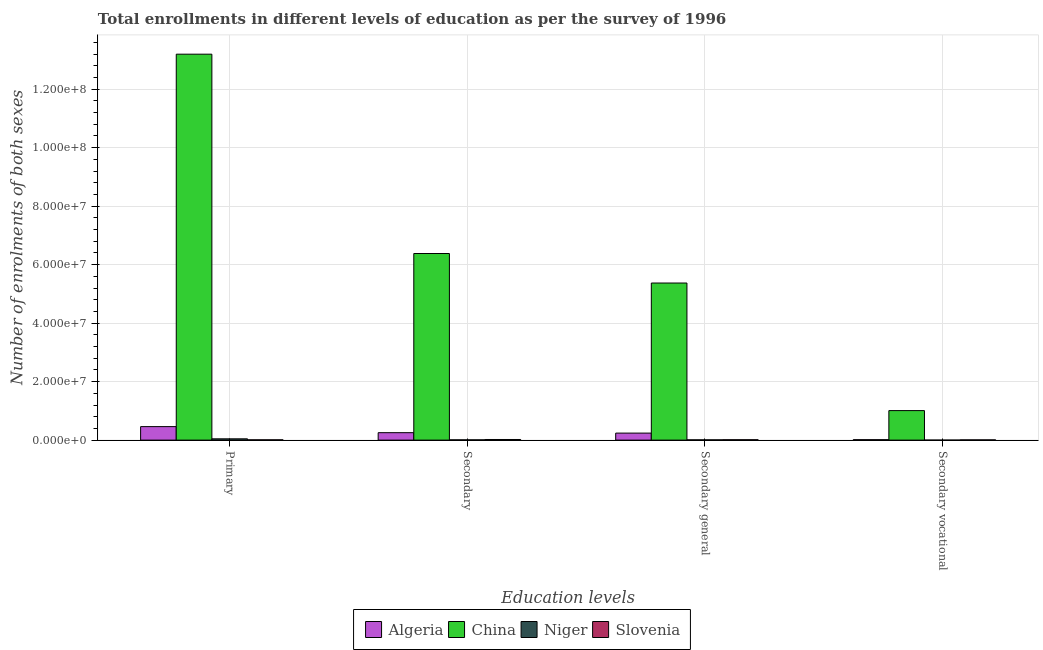How many groups of bars are there?
Your answer should be very brief. 4. How many bars are there on the 3rd tick from the right?
Offer a terse response. 4. What is the label of the 3rd group of bars from the left?
Give a very brief answer. Secondary general. What is the number of enrolments in secondary general education in Algeria?
Provide a succinct answer. 2.40e+06. Across all countries, what is the maximum number of enrolments in secondary vocational education?
Provide a succinct answer. 1.01e+07. Across all countries, what is the minimum number of enrolments in secondary general education?
Make the answer very short. 9.05e+04. In which country was the number of enrolments in secondary general education minimum?
Your answer should be very brief. Niger. What is the total number of enrolments in secondary vocational education in the graph?
Give a very brief answer. 1.03e+07. What is the difference between the number of enrolments in secondary general education in Slovenia and that in Algeria?
Offer a very short reply. -2.26e+06. What is the difference between the number of enrolments in secondary vocational education in China and the number of enrolments in secondary general education in Niger?
Your response must be concise. 1.00e+07. What is the average number of enrolments in secondary general education per country?
Your response must be concise. 1.41e+07. What is the difference between the number of enrolments in secondary education and number of enrolments in primary education in Algeria?
Make the answer very short. -2.07e+06. What is the ratio of the number of enrolments in secondary general education in Slovenia to that in Niger?
Offer a terse response. 1.48. Is the number of enrolments in secondary general education in China less than that in Niger?
Your response must be concise. No. Is the difference between the number of enrolments in primary education in Niger and Algeria greater than the difference between the number of enrolments in secondary vocational education in Niger and Algeria?
Offer a terse response. No. What is the difference between the highest and the second highest number of enrolments in primary education?
Keep it short and to the point. 1.27e+08. What is the difference between the highest and the lowest number of enrolments in secondary vocational education?
Your answer should be compact. 1.01e+07. In how many countries, is the number of enrolments in secondary vocational education greater than the average number of enrolments in secondary vocational education taken over all countries?
Offer a terse response. 1. Is the sum of the number of enrolments in secondary education in Niger and China greater than the maximum number of enrolments in secondary general education across all countries?
Your answer should be compact. Yes. What does the 1st bar from the left in Primary represents?
Make the answer very short. Algeria. What does the 2nd bar from the right in Secondary general represents?
Keep it short and to the point. Niger. How many countries are there in the graph?
Make the answer very short. 4. What is the difference between two consecutive major ticks on the Y-axis?
Your response must be concise. 2.00e+07. Does the graph contain grids?
Offer a terse response. Yes. Where does the legend appear in the graph?
Keep it short and to the point. Bottom center. What is the title of the graph?
Provide a succinct answer. Total enrollments in different levels of education as per the survey of 1996. Does "United Kingdom" appear as one of the legend labels in the graph?
Provide a short and direct response. No. What is the label or title of the X-axis?
Offer a terse response. Education levels. What is the label or title of the Y-axis?
Ensure brevity in your answer.  Number of enrolments of both sexes. What is the Number of enrolments of both sexes of Algeria in Primary?
Your answer should be compact. 4.62e+06. What is the Number of enrolments of both sexes of China in Primary?
Give a very brief answer. 1.32e+08. What is the Number of enrolments of both sexes in Niger in Primary?
Give a very brief answer. 4.41e+05. What is the Number of enrolments of both sexes in Slovenia in Primary?
Your response must be concise. 1.01e+05. What is the Number of enrolments of both sexes in Algeria in Secondary?
Ensure brevity in your answer.  2.54e+06. What is the Number of enrolments of both sexes in China in Secondary?
Keep it short and to the point. 6.38e+07. What is the Number of enrolments of both sexes of Niger in Secondary?
Provide a succinct answer. 9.26e+04. What is the Number of enrolments of both sexes in Slovenia in Secondary?
Offer a very short reply. 2.12e+05. What is the Number of enrolments of both sexes in Algeria in Secondary general?
Keep it short and to the point. 2.40e+06. What is the Number of enrolments of both sexes of China in Secondary general?
Make the answer very short. 5.37e+07. What is the Number of enrolments of both sexes in Niger in Secondary general?
Provide a short and direct response. 9.05e+04. What is the Number of enrolments of both sexes of Slovenia in Secondary general?
Ensure brevity in your answer.  1.34e+05. What is the Number of enrolments of both sexes of Algeria in Secondary vocational?
Offer a very short reply. 1.47e+05. What is the Number of enrolments of both sexes of China in Secondary vocational?
Your answer should be very brief. 1.01e+07. What is the Number of enrolments of both sexes of Niger in Secondary vocational?
Provide a succinct answer. 2138. What is the Number of enrolments of both sexes in Slovenia in Secondary vocational?
Keep it short and to the point. 7.83e+04. Across all Education levels, what is the maximum Number of enrolments of both sexes of Algeria?
Provide a succinct answer. 4.62e+06. Across all Education levels, what is the maximum Number of enrolments of both sexes in China?
Offer a terse response. 1.32e+08. Across all Education levels, what is the maximum Number of enrolments of both sexes of Niger?
Offer a terse response. 4.41e+05. Across all Education levels, what is the maximum Number of enrolments of both sexes in Slovenia?
Make the answer very short. 2.12e+05. Across all Education levels, what is the minimum Number of enrolments of both sexes in Algeria?
Keep it short and to the point. 1.47e+05. Across all Education levels, what is the minimum Number of enrolments of both sexes in China?
Keep it short and to the point. 1.01e+07. Across all Education levels, what is the minimum Number of enrolments of both sexes in Niger?
Make the answer very short. 2138. Across all Education levels, what is the minimum Number of enrolments of both sexes in Slovenia?
Give a very brief answer. 7.83e+04. What is the total Number of enrolments of both sexes of Algeria in the graph?
Your answer should be compact. 9.71e+06. What is the total Number of enrolments of both sexes in China in the graph?
Provide a succinct answer. 2.60e+08. What is the total Number of enrolments of both sexes of Niger in the graph?
Your answer should be very brief. 6.26e+05. What is the total Number of enrolments of both sexes in Slovenia in the graph?
Provide a succinct answer. 5.25e+05. What is the difference between the Number of enrolments of both sexes of Algeria in Primary and that in Secondary?
Provide a succinct answer. 2.07e+06. What is the difference between the Number of enrolments of both sexes of China in Primary and that in Secondary?
Your answer should be compact. 6.82e+07. What is the difference between the Number of enrolments of both sexes in Niger in Primary and that in Secondary?
Make the answer very short. 3.48e+05. What is the difference between the Number of enrolments of both sexes in Slovenia in Primary and that in Secondary?
Ensure brevity in your answer.  -1.11e+05. What is the difference between the Number of enrolments of both sexes in Algeria in Primary and that in Secondary general?
Provide a succinct answer. 2.22e+06. What is the difference between the Number of enrolments of both sexes of China in Primary and that in Secondary general?
Provide a short and direct response. 7.82e+07. What is the difference between the Number of enrolments of both sexes in Niger in Primary and that in Secondary general?
Provide a succinct answer. 3.50e+05. What is the difference between the Number of enrolments of both sexes of Slovenia in Primary and that in Secondary general?
Provide a short and direct response. -3.30e+04. What is the difference between the Number of enrolments of both sexes in Algeria in Primary and that in Secondary vocational?
Your answer should be compact. 4.47e+06. What is the difference between the Number of enrolments of both sexes of China in Primary and that in Secondary vocational?
Offer a terse response. 1.22e+08. What is the difference between the Number of enrolments of both sexes in Niger in Primary and that in Secondary vocational?
Give a very brief answer. 4.38e+05. What is the difference between the Number of enrolments of both sexes in Slovenia in Primary and that in Secondary vocational?
Keep it short and to the point. 2.25e+04. What is the difference between the Number of enrolments of both sexes in Algeria in Secondary and that in Secondary general?
Your answer should be compact. 1.47e+05. What is the difference between the Number of enrolments of both sexes in China in Secondary and that in Secondary general?
Your response must be concise. 1.01e+07. What is the difference between the Number of enrolments of both sexes of Niger in Secondary and that in Secondary general?
Offer a terse response. 2138. What is the difference between the Number of enrolments of both sexes of Slovenia in Secondary and that in Secondary general?
Give a very brief answer. 7.83e+04. What is the difference between the Number of enrolments of both sexes in Algeria in Secondary and that in Secondary vocational?
Your answer should be very brief. 2.40e+06. What is the difference between the Number of enrolments of both sexes of China in Secondary and that in Secondary vocational?
Offer a very short reply. 5.37e+07. What is the difference between the Number of enrolments of both sexes in Niger in Secondary and that in Secondary vocational?
Provide a succinct answer. 9.05e+04. What is the difference between the Number of enrolments of both sexes of Slovenia in Secondary and that in Secondary vocational?
Your answer should be compact. 1.34e+05. What is the difference between the Number of enrolments of both sexes in Algeria in Secondary general and that in Secondary vocational?
Keep it short and to the point. 2.25e+06. What is the difference between the Number of enrolments of both sexes of China in Secondary general and that in Secondary vocational?
Your answer should be very brief. 4.36e+07. What is the difference between the Number of enrolments of both sexes of Niger in Secondary general and that in Secondary vocational?
Keep it short and to the point. 8.83e+04. What is the difference between the Number of enrolments of both sexes of Slovenia in Secondary general and that in Secondary vocational?
Offer a terse response. 5.55e+04. What is the difference between the Number of enrolments of both sexes in Algeria in Primary and the Number of enrolments of both sexes in China in Secondary?
Make the answer very short. -5.92e+07. What is the difference between the Number of enrolments of both sexes in Algeria in Primary and the Number of enrolments of both sexes in Niger in Secondary?
Your response must be concise. 4.53e+06. What is the difference between the Number of enrolments of both sexes in Algeria in Primary and the Number of enrolments of both sexes in Slovenia in Secondary?
Your response must be concise. 4.41e+06. What is the difference between the Number of enrolments of both sexes of China in Primary and the Number of enrolments of both sexes of Niger in Secondary?
Provide a short and direct response. 1.32e+08. What is the difference between the Number of enrolments of both sexes in China in Primary and the Number of enrolments of both sexes in Slovenia in Secondary?
Give a very brief answer. 1.32e+08. What is the difference between the Number of enrolments of both sexes of Niger in Primary and the Number of enrolments of both sexes of Slovenia in Secondary?
Your answer should be very brief. 2.29e+05. What is the difference between the Number of enrolments of both sexes of Algeria in Primary and the Number of enrolments of both sexes of China in Secondary general?
Provide a succinct answer. -4.91e+07. What is the difference between the Number of enrolments of both sexes in Algeria in Primary and the Number of enrolments of both sexes in Niger in Secondary general?
Your response must be concise. 4.53e+06. What is the difference between the Number of enrolments of both sexes of Algeria in Primary and the Number of enrolments of both sexes of Slovenia in Secondary general?
Your response must be concise. 4.48e+06. What is the difference between the Number of enrolments of both sexes in China in Primary and the Number of enrolments of both sexes in Niger in Secondary general?
Make the answer very short. 1.32e+08. What is the difference between the Number of enrolments of both sexes in China in Primary and the Number of enrolments of both sexes in Slovenia in Secondary general?
Provide a succinct answer. 1.32e+08. What is the difference between the Number of enrolments of both sexes of Niger in Primary and the Number of enrolments of both sexes of Slovenia in Secondary general?
Your response must be concise. 3.07e+05. What is the difference between the Number of enrolments of both sexes in Algeria in Primary and the Number of enrolments of both sexes in China in Secondary vocational?
Make the answer very short. -5.47e+06. What is the difference between the Number of enrolments of both sexes of Algeria in Primary and the Number of enrolments of both sexes of Niger in Secondary vocational?
Give a very brief answer. 4.62e+06. What is the difference between the Number of enrolments of both sexes in Algeria in Primary and the Number of enrolments of both sexes in Slovenia in Secondary vocational?
Offer a terse response. 4.54e+06. What is the difference between the Number of enrolments of both sexes of China in Primary and the Number of enrolments of both sexes of Niger in Secondary vocational?
Offer a terse response. 1.32e+08. What is the difference between the Number of enrolments of both sexes in China in Primary and the Number of enrolments of both sexes in Slovenia in Secondary vocational?
Give a very brief answer. 1.32e+08. What is the difference between the Number of enrolments of both sexes in Niger in Primary and the Number of enrolments of both sexes in Slovenia in Secondary vocational?
Provide a short and direct response. 3.62e+05. What is the difference between the Number of enrolments of both sexes of Algeria in Secondary and the Number of enrolments of both sexes of China in Secondary general?
Provide a short and direct response. -5.12e+07. What is the difference between the Number of enrolments of both sexes of Algeria in Secondary and the Number of enrolments of both sexes of Niger in Secondary general?
Your answer should be very brief. 2.45e+06. What is the difference between the Number of enrolments of both sexes of Algeria in Secondary and the Number of enrolments of both sexes of Slovenia in Secondary general?
Ensure brevity in your answer.  2.41e+06. What is the difference between the Number of enrolments of both sexes of China in Secondary and the Number of enrolments of both sexes of Niger in Secondary general?
Give a very brief answer. 6.37e+07. What is the difference between the Number of enrolments of both sexes in China in Secondary and the Number of enrolments of both sexes in Slovenia in Secondary general?
Provide a short and direct response. 6.37e+07. What is the difference between the Number of enrolments of both sexes of Niger in Secondary and the Number of enrolments of both sexes of Slovenia in Secondary general?
Make the answer very short. -4.12e+04. What is the difference between the Number of enrolments of both sexes of Algeria in Secondary and the Number of enrolments of both sexes of China in Secondary vocational?
Your answer should be very brief. -7.55e+06. What is the difference between the Number of enrolments of both sexes in Algeria in Secondary and the Number of enrolments of both sexes in Niger in Secondary vocational?
Provide a succinct answer. 2.54e+06. What is the difference between the Number of enrolments of both sexes of Algeria in Secondary and the Number of enrolments of both sexes of Slovenia in Secondary vocational?
Your answer should be very brief. 2.47e+06. What is the difference between the Number of enrolments of both sexes of China in Secondary and the Number of enrolments of both sexes of Niger in Secondary vocational?
Ensure brevity in your answer.  6.38e+07. What is the difference between the Number of enrolments of both sexes of China in Secondary and the Number of enrolments of both sexes of Slovenia in Secondary vocational?
Provide a succinct answer. 6.37e+07. What is the difference between the Number of enrolments of both sexes of Niger in Secondary and the Number of enrolments of both sexes of Slovenia in Secondary vocational?
Give a very brief answer. 1.43e+04. What is the difference between the Number of enrolments of both sexes of Algeria in Secondary general and the Number of enrolments of both sexes of China in Secondary vocational?
Give a very brief answer. -7.69e+06. What is the difference between the Number of enrolments of both sexes in Algeria in Secondary general and the Number of enrolments of both sexes in Niger in Secondary vocational?
Your response must be concise. 2.40e+06. What is the difference between the Number of enrolments of both sexes of Algeria in Secondary general and the Number of enrolments of both sexes of Slovenia in Secondary vocational?
Offer a very short reply. 2.32e+06. What is the difference between the Number of enrolments of both sexes in China in Secondary general and the Number of enrolments of both sexes in Niger in Secondary vocational?
Provide a succinct answer. 5.37e+07. What is the difference between the Number of enrolments of both sexes in China in Secondary general and the Number of enrolments of both sexes in Slovenia in Secondary vocational?
Ensure brevity in your answer.  5.36e+07. What is the difference between the Number of enrolments of both sexes in Niger in Secondary general and the Number of enrolments of both sexes in Slovenia in Secondary vocational?
Offer a terse response. 1.22e+04. What is the average Number of enrolments of both sexes in Algeria per Education levels?
Your answer should be very brief. 2.43e+06. What is the average Number of enrolments of both sexes in China per Education levels?
Provide a succinct answer. 6.49e+07. What is the average Number of enrolments of both sexes of Niger per Education levels?
Your answer should be compact. 1.56e+05. What is the average Number of enrolments of both sexes of Slovenia per Education levels?
Offer a terse response. 1.31e+05. What is the difference between the Number of enrolments of both sexes of Algeria and Number of enrolments of both sexes of China in Primary?
Offer a terse response. -1.27e+08. What is the difference between the Number of enrolments of both sexes in Algeria and Number of enrolments of both sexes in Niger in Primary?
Give a very brief answer. 4.18e+06. What is the difference between the Number of enrolments of both sexes of Algeria and Number of enrolments of both sexes of Slovenia in Primary?
Keep it short and to the point. 4.52e+06. What is the difference between the Number of enrolments of both sexes of China and Number of enrolments of both sexes of Niger in Primary?
Give a very brief answer. 1.32e+08. What is the difference between the Number of enrolments of both sexes of China and Number of enrolments of both sexes of Slovenia in Primary?
Keep it short and to the point. 1.32e+08. What is the difference between the Number of enrolments of both sexes in Niger and Number of enrolments of both sexes in Slovenia in Primary?
Offer a terse response. 3.40e+05. What is the difference between the Number of enrolments of both sexes of Algeria and Number of enrolments of both sexes of China in Secondary?
Keep it short and to the point. -6.13e+07. What is the difference between the Number of enrolments of both sexes of Algeria and Number of enrolments of both sexes of Niger in Secondary?
Offer a terse response. 2.45e+06. What is the difference between the Number of enrolments of both sexes in Algeria and Number of enrolments of both sexes in Slovenia in Secondary?
Give a very brief answer. 2.33e+06. What is the difference between the Number of enrolments of both sexes of China and Number of enrolments of both sexes of Niger in Secondary?
Provide a short and direct response. 6.37e+07. What is the difference between the Number of enrolments of both sexes of China and Number of enrolments of both sexes of Slovenia in Secondary?
Give a very brief answer. 6.36e+07. What is the difference between the Number of enrolments of both sexes in Niger and Number of enrolments of both sexes in Slovenia in Secondary?
Ensure brevity in your answer.  -1.19e+05. What is the difference between the Number of enrolments of both sexes of Algeria and Number of enrolments of both sexes of China in Secondary general?
Give a very brief answer. -5.13e+07. What is the difference between the Number of enrolments of both sexes of Algeria and Number of enrolments of both sexes of Niger in Secondary general?
Offer a very short reply. 2.31e+06. What is the difference between the Number of enrolments of both sexes of Algeria and Number of enrolments of both sexes of Slovenia in Secondary general?
Your answer should be compact. 2.26e+06. What is the difference between the Number of enrolments of both sexes of China and Number of enrolments of both sexes of Niger in Secondary general?
Give a very brief answer. 5.36e+07. What is the difference between the Number of enrolments of both sexes in China and Number of enrolments of both sexes in Slovenia in Secondary general?
Ensure brevity in your answer.  5.36e+07. What is the difference between the Number of enrolments of both sexes of Niger and Number of enrolments of both sexes of Slovenia in Secondary general?
Your response must be concise. -4.33e+04. What is the difference between the Number of enrolments of both sexes in Algeria and Number of enrolments of both sexes in China in Secondary vocational?
Your answer should be compact. -9.94e+06. What is the difference between the Number of enrolments of both sexes in Algeria and Number of enrolments of both sexes in Niger in Secondary vocational?
Provide a short and direct response. 1.45e+05. What is the difference between the Number of enrolments of both sexes of Algeria and Number of enrolments of both sexes of Slovenia in Secondary vocational?
Make the answer very short. 6.91e+04. What is the difference between the Number of enrolments of both sexes in China and Number of enrolments of both sexes in Niger in Secondary vocational?
Keep it short and to the point. 1.01e+07. What is the difference between the Number of enrolments of both sexes of China and Number of enrolments of both sexes of Slovenia in Secondary vocational?
Make the answer very short. 1.00e+07. What is the difference between the Number of enrolments of both sexes of Niger and Number of enrolments of both sexes of Slovenia in Secondary vocational?
Provide a succinct answer. -7.61e+04. What is the ratio of the Number of enrolments of both sexes in Algeria in Primary to that in Secondary?
Ensure brevity in your answer.  1.81. What is the ratio of the Number of enrolments of both sexes of China in Primary to that in Secondary?
Keep it short and to the point. 2.07. What is the ratio of the Number of enrolments of both sexes of Niger in Primary to that in Secondary?
Ensure brevity in your answer.  4.76. What is the ratio of the Number of enrolments of both sexes in Slovenia in Primary to that in Secondary?
Offer a very short reply. 0.48. What is the ratio of the Number of enrolments of both sexes of Algeria in Primary to that in Secondary general?
Give a very brief answer. 1.93. What is the ratio of the Number of enrolments of both sexes in China in Primary to that in Secondary general?
Offer a very short reply. 2.46. What is the ratio of the Number of enrolments of both sexes of Niger in Primary to that in Secondary general?
Provide a succinct answer. 4.87. What is the ratio of the Number of enrolments of both sexes of Slovenia in Primary to that in Secondary general?
Provide a succinct answer. 0.75. What is the ratio of the Number of enrolments of both sexes of Algeria in Primary to that in Secondary vocational?
Your answer should be compact. 31.32. What is the ratio of the Number of enrolments of both sexes in China in Primary to that in Secondary vocational?
Provide a short and direct response. 13.08. What is the ratio of the Number of enrolments of both sexes in Niger in Primary to that in Secondary vocational?
Offer a terse response. 206.09. What is the ratio of the Number of enrolments of both sexes in Slovenia in Primary to that in Secondary vocational?
Provide a short and direct response. 1.29. What is the ratio of the Number of enrolments of both sexes in Algeria in Secondary to that in Secondary general?
Provide a short and direct response. 1.06. What is the ratio of the Number of enrolments of both sexes in China in Secondary to that in Secondary general?
Ensure brevity in your answer.  1.19. What is the ratio of the Number of enrolments of both sexes in Niger in Secondary to that in Secondary general?
Your response must be concise. 1.02. What is the ratio of the Number of enrolments of both sexes of Slovenia in Secondary to that in Secondary general?
Provide a succinct answer. 1.59. What is the ratio of the Number of enrolments of both sexes in Algeria in Secondary to that in Secondary vocational?
Give a very brief answer. 17.26. What is the ratio of the Number of enrolments of both sexes in China in Secondary to that in Secondary vocational?
Provide a succinct answer. 6.32. What is the ratio of the Number of enrolments of both sexes of Niger in Secondary to that in Secondary vocational?
Keep it short and to the point. 43.32. What is the ratio of the Number of enrolments of both sexes of Slovenia in Secondary to that in Secondary vocational?
Offer a very short reply. 2.71. What is the ratio of the Number of enrolments of both sexes in Algeria in Secondary general to that in Secondary vocational?
Make the answer very short. 16.26. What is the ratio of the Number of enrolments of both sexes in China in Secondary general to that in Secondary vocational?
Your answer should be very brief. 5.32. What is the ratio of the Number of enrolments of both sexes in Niger in Secondary general to that in Secondary vocational?
Keep it short and to the point. 42.32. What is the ratio of the Number of enrolments of both sexes in Slovenia in Secondary general to that in Secondary vocational?
Offer a very short reply. 1.71. What is the difference between the highest and the second highest Number of enrolments of both sexes of Algeria?
Ensure brevity in your answer.  2.07e+06. What is the difference between the highest and the second highest Number of enrolments of both sexes of China?
Give a very brief answer. 6.82e+07. What is the difference between the highest and the second highest Number of enrolments of both sexes of Niger?
Your answer should be very brief. 3.48e+05. What is the difference between the highest and the second highest Number of enrolments of both sexes in Slovenia?
Ensure brevity in your answer.  7.83e+04. What is the difference between the highest and the lowest Number of enrolments of both sexes in Algeria?
Your answer should be compact. 4.47e+06. What is the difference between the highest and the lowest Number of enrolments of both sexes of China?
Offer a terse response. 1.22e+08. What is the difference between the highest and the lowest Number of enrolments of both sexes of Niger?
Ensure brevity in your answer.  4.38e+05. What is the difference between the highest and the lowest Number of enrolments of both sexes in Slovenia?
Provide a short and direct response. 1.34e+05. 